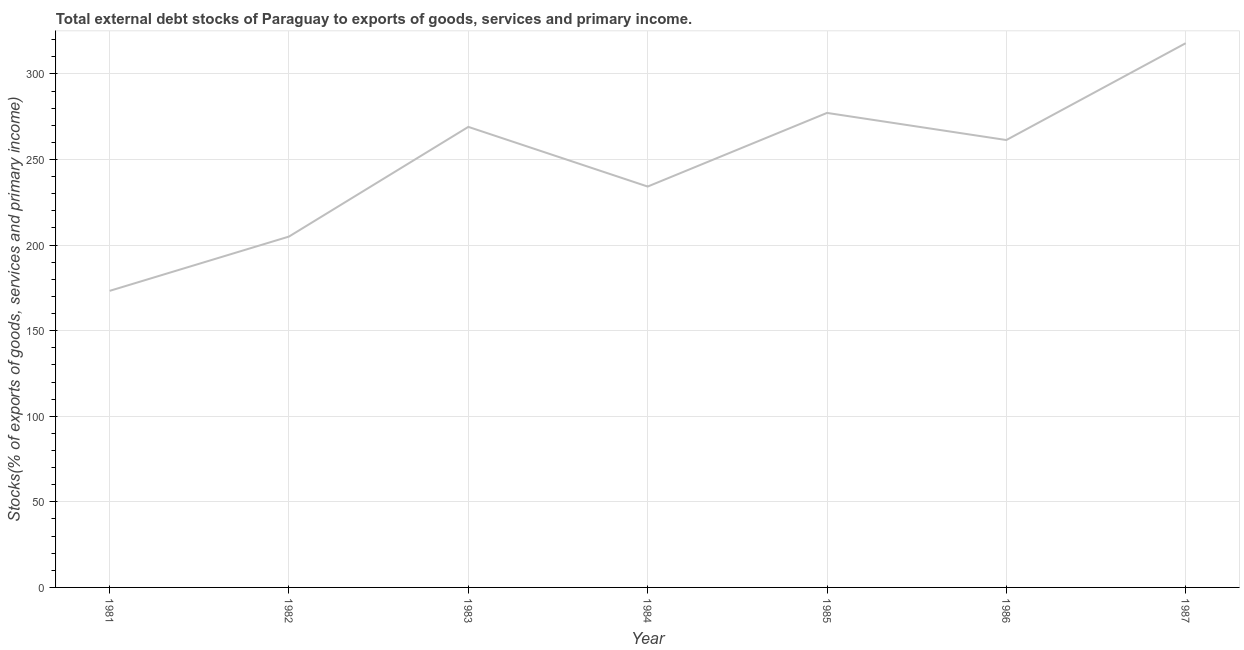What is the external debt stocks in 1984?
Provide a short and direct response. 234.2. Across all years, what is the maximum external debt stocks?
Provide a short and direct response. 317.94. Across all years, what is the minimum external debt stocks?
Ensure brevity in your answer.  173.26. What is the sum of the external debt stocks?
Your answer should be very brief. 1738.05. What is the difference between the external debt stocks in 1981 and 1986?
Provide a short and direct response. -88.12. What is the average external debt stocks per year?
Provide a short and direct response. 248.29. What is the median external debt stocks?
Your answer should be very brief. 261.38. In how many years, is the external debt stocks greater than 300 %?
Your response must be concise. 1. What is the ratio of the external debt stocks in 1985 to that in 1986?
Your answer should be very brief. 1.06. Is the difference between the external debt stocks in 1981 and 1983 greater than the difference between any two years?
Give a very brief answer. No. What is the difference between the highest and the second highest external debt stocks?
Your answer should be very brief. 40.72. What is the difference between the highest and the lowest external debt stocks?
Offer a terse response. 144.68. In how many years, is the external debt stocks greater than the average external debt stocks taken over all years?
Make the answer very short. 4. What is the difference between two consecutive major ticks on the Y-axis?
Provide a succinct answer. 50. Does the graph contain any zero values?
Your answer should be very brief. No. What is the title of the graph?
Provide a short and direct response. Total external debt stocks of Paraguay to exports of goods, services and primary income. What is the label or title of the X-axis?
Your answer should be very brief. Year. What is the label or title of the Y-axis?
Offer a terse response. Stocks(% of exports of goods, services and primary income). What is the Stocks(% of exports of goods, services and primary income) in 1981?
Keep it short and to the point. 173.26. What is the Stocks(% of exports of goods, services and primary income) in 1982?
Give a very brief answer. 204.98. What is the Stocks(% of exports of goods, services and primary income) in 1983?
Offer a terse response. 269.06. What is the Stocks(% of exports of goods, services and primary income) of 1984?
Your response must be concise. 234.2. What is the Stocks(% of exports of goods, services and primary income) in 1985?
Provide a succinct answer. 277.22. What is the Stocks(% of exports of goods, services and primary income) of 1986?
Offer a very short reply. 261.38. What is the Stocks(% of exports of goods, services and primary income) of 1987?
Provide a short and direct response. 317.94. What is the difference between the Stocks(% of exports of goods, services and primary income) in 1981 and 1982?
Your answer should be very brief. -31.72. What is the difference between the Stocks(% of exports of goods, services and primary income) in 1981 and 1983?
Provide a short and direct response. -95.8. What is the difference between the Stocks(% of exports of goods, services and primary income) in 1981 and 1984?
Give a very brief answer. -60.94. What is the difference between the Stocks(% of exports of goods, services and primary income) in 1981 and 1985?
Offer a terse response. -103.96. What is the difference between the Stocks(% of exports of goods, services and primary income) in 1981 and 1986?
Keep it short and to the point. -88.12. What is the difference between the Stocks(% of exports of goods, services and primary income) in 1981 and 1987?
Provide a short and direct response. -144.68. What is the difference between the Stocks(% of exports of goods, services and primary income) in 1982 and 1983?
Ensure brevity in your answer.  -64.08. What is the difference between the Stocks(% of exports of goods, services and primary income) in 1982 and 1984?
Provide a short and direct response. -29.22. What is the difference between the Stocks(% of exports of goods, services and primary income) in 1982 and 1985?
Your response must be concise. -72.24. What is the difference between the Stocks(% of exports of goods, services and primary income) in 1982 and 1986?
Your response must be concise. -56.4. What is the difference between the Stocks(% of exports of goods, services and primary income) in 1982 and 1987?
Your answer should be very brief. -112.96. What is the difference between the Stocks(% of exports of goods, services and primary income) in 1983 and 1984?
Make the answer very short. 34.86. What is the difference between the Stocks(% of exports of goods, services and primary income) in 1983 and 1985?
Make the answer very short. -8.16. What is the difference between the Stocks(% of exports of goods, services and primary income) in 1983 and 1986?
Provide a succinct answer. 7.68. What is the difference between the Stocks(% of exports of goods, services and primary income) in 1983 and 1987?
Ensure brevity in your answer.  -48.88. What is the difference between the Stocks(% of exports of goods, services and primary income) in 1984 and 1985?
Keep it short and to the point. -43.02. What is the difference between the Stocks(% of exports of goods, services and primary income) in 1984 and 1986?
Keep it short and to the point. -27.18. What is the difference between the Stocks(% of exports of goods, services and primary income) in 1984 and 1987?
Provide a short and direct response. -83.74. What is the difference between the Stocks(% of exports of goods, services and primary income) in 1985 and 1986?
Give a very brief answer. 15.84. What is the difference between the Stocks(% of exports of goods, services and primary income) in 1985 and 1987?
Provide a succinct answer. -40.72. What is the difference between the Stocks(% of exports of goods, services and primary income) in 1986 and 1987?
Keep it short and to the point. -56.56. What is the ratio of the Stocks(% of exports of goods, services and primary income) in 1981 to that in 1982?
Your answer should be compact. 0.84. What is the ratio of the Stocks(% of exports of goods, services and primary income) in 1981 to that in 1983?
Give a very brief answer. 0.64. What is the ratio of the Stocks(% of exports of goods, services and primary income) in 1981 to that in 1984?
Your answer should be compact. 0.74. What is the ratio of the Stocks(% of exports of goods, services and primary income) in 1981 to that in 1985?
Your answer should be very brief. 0.62. What is the ratio of the Stocks(% of exports of goods, services and primary income) in 1981 to that in 1986?
Give a very brief answer. 0.66. What is the ratio of the Stocks(% of exports of goods, services and primary income) in 1981 to that in 1987?
Ensure brevity in your answer.  0.55. What is the ratio of the Stocks(% of exports of goods, services and primary income) in 1982 to that in 1983?
Your answer should be very brief. 0.76. What is the ratio of the Stocks(% of exports of goods, services and primary income) in 1982 to that in 1984?
Provide a short and direct response. 0.88. What is the ratio of the Stocks(% of exports of goods, services and primary income) in 1982 to that in 1985?
Keep it short and to the point. 0.74. What is the ratio of the Stocks(% of exports of goods, services and primary income) in 1982 to that in 1986?
Give a very brief answer. 0.78. What is the ratio of the Stocks(% of exports of goods, services and primary income) in 1982 to that in 1987?
Keep it short and to the point. 0.65. What is the ratio of the Stocks(% of exports of goods, services and primary income) in 1983 to that in 1984?
Make the answer very short. 1.15. What is the ratio of the Stocks(% of exports of goods, services and primary income) in 1983 to that in 1985?
Your answer should be compact. 0.97. What is the ratio of the Stocks(% of exports of goods, services and primary income) in 1983 to that in 1987?
Make the answer very short. 0.85. What is the ratio of the Stocks(% of exports of goods, services and primary income) in 1984 to that in 1985?
Ensure brevity in your answer.  0.84. What is the ratio of the Stocks(% of exports of goods, services and primary income) in 1984 to that in 1986?
Keep it short and to the point. 0.9. What is the ratio of the Stocks(% of exports of goods, services and primary income) in 1984 to that in 1987?
Make the answer very short. 0.74. What is the ratio of the Stocks(% of exports of goods, services and primary income) in 1985 to that in 1986?
Offer a terse response. 1.06. What is the ratio of the Stocks(% of exports of goods, services and primary income) in 1985 to that in 1987?
Your response must be concise. 0.87. What is the ratio of the Stocks(% of exports of goods, services and primary income) in 1986 to that in 1987?
Give a very brief answer. 0.82. 